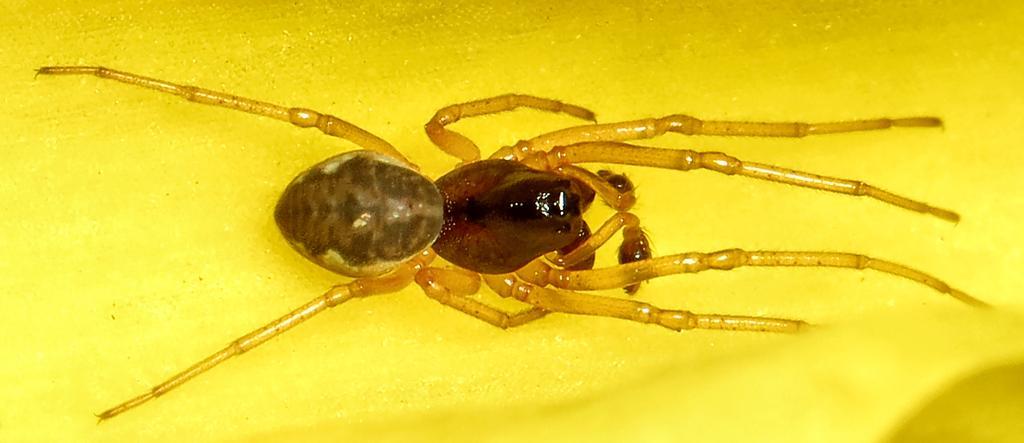Please provide a concise description of this image. There is an insect in the center of the image and the background is yellow in color. 